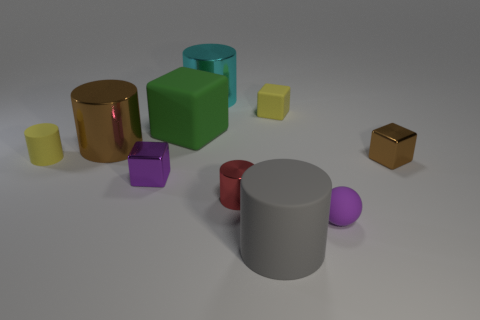There is a yellow thing to the left of the small purple metallic cube; is its shape the same as the large brown thing?
Give a very brief answer. Yes. Are there any tiny metallic cubes on the left side of the red thing?
Make the answer very short. Yes. How many tiny things are cyan cylinders or red metallic cylinders?
Your answer should be compact. 1. Do the tiny yellow block and the gray thing have the same material?
Make the answer very short. Yes. Are there any objects that have the same color as the small matte cube?
Keep it short and to the point. Yes. What is the size of the cyan cylinder that is made of the same material as the brown cube?
Your answer should be very brief. Large. There is a small yellow thing that is on the left side of the big shiny cylinder behind the small yellow object that is right of the cyan metallic object; what shape is it?
Provide a succinct answer. Cylinder. There is a cyan metallic object that is the same shape as the small red metal object; what size is it?
Your response must be concise. Large. There is a thing that is both right of the small yellow matte block and in front of the tiny red shiny thing; what is its size?
Keep it short and to the point. Small. What is the shape of the small shiny thing that is the same color as the small matte ball?
Provide a succinct answer. Cube. 